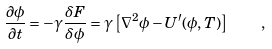<formula> <loc_0><loc_0><loc_500><loc_500>\frac { \partial \phi } { \partial t } = - \gamma \frac { \delta F } { \delta \phi } = \gamma \left [ \nabla ^ { 2 } \phi - U ^ { \prime } ( \phi , T ) \right ] \quad ,</formula> 